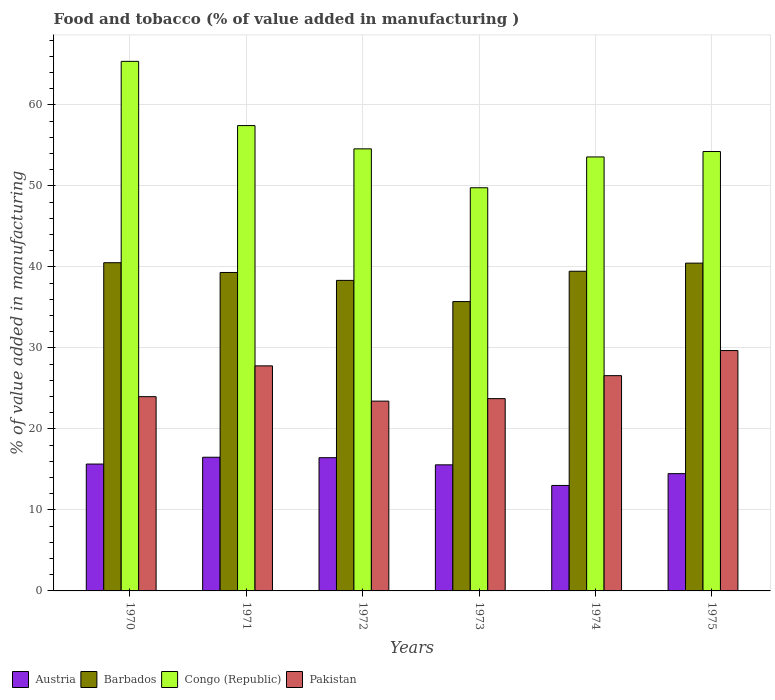How many different coloured bars are there?
Provide a short and direct response. 4. Are the number of bars per tick equal to the number of legend labels?
Provide a short and direct response. Yes. How many bars are there on the 2nd tick from the left?
Ensure brevity in your answer.  4. How many bars are there on the 2nd tick from the right?
Provide a short and direct response. 4. What is the label of the 6th group of bars from the left?
Your answer should be very brief. 1975. What is the value added in manufacturing food and tobacco in Pakistan in 1971?
Give a very brief answer. 27.78. Across all years, what is the maximum value added in manufacturing food and tobacco in Pakistan?
Ensure brevity in your answer.  29.67. Across all years, what is the minimum value added in manufacturing food and tobacco in Austria?
Your response must be concise. 13.02. In which year was the value added in manufacturing food and tobacco in Austria minimum?
Your answer should be very brief. 1974. What is the total value added in manufacturing food and tobacco in Barbados in the graph?
Your answer should be very brief. 233.8. What is the difference between the value added in manufacturing food and tobacco in Barbados in 1970 and that in 1975?
Keep it short and to the point. 0.05. What is the difference between the value added in manufacturing food and tobacco in Congo (Republic) in 1972 and the value added in manufacturing food and tobacco in Pakistan in 1971?
Offer a terse response. 26.79. What is the average value added in manufacturing food and tobacco in Congo (Republic) per year?
Keep it short and to the point. 55.83. In the year 1973, what is the difference between the value added in manufacturing food and tobacco in Congo (Republic) and value added in manufacturing food and tobacco in Austria?
Your answer should be compact. 34.2. In how many years, is the value added in manufacturing food and tobacco in Austria greater than 42 %?
Your answer should be compact. 0. What is the ratio of the value added in manufacturing food and tobacco in Congo (Republic) in 1973 to that in 1974?
Provide a short and direct response. 0.93. Is the value added in manufacturing food and tobacco in Barbados in 1970 less than that in 1973?
Your answer should be compact. No. Is the difference between the value added in manufacturing food and tobacco in Congo (Republic) in 1972 and 1975 greater than the difference between the value added in manufacturing food and tobacco in Austria in 1972 and 1975?
Give a very brief answer. No. What is the difference between the highest and the second highest value added in manufacturing food and tobacco in Barbados?
Keep it short and to the point. 0.05. What is the difference between the highest and the lowest value added in manufacturing food and tobacco in Barbados?
Keep it short and to the point. 4.8. In how many years, is the value added in manufacturing food and tobacco in Congo (Republic) greater than the average value added in manufacturing food and tobacco in Congo (Republic) taken over all years?
Ensure brevity in your answer.  2. Is the sum of the value added in manufacturing food and tobacco in Barbados in 1974 and 1975 greater than the maximum value added in manufacturing food and tobacco in Congo (Republic) across all years?
Offer a terse response. Yes. What does the 4th bar from the left in 1971 represents?
Provide a short and direct response. Pakistan. What is the difference between two consecutive major ticks on the Y-axis?
Your answer should be very brief. 10. How are the legend labels stacked?
Your answer should be very brief. Horizontal. What is the title of the graph?
Keep it short and to the point. Food and tobacco (% of value added in manufacturing ). Does "New Caledonia" appear as one of the legend labels in the graph?
Your answer should be compact. No. What is the label or title of the Y-axis?
Make the answer very short. % of value added in manufacturing. What is the % of value added in manufacturing of Austria in 1970?
Offer a terse response. 15.66. What is the % of value added in manufacturing of Barbados in 1970?
Offer a terse response. 40.51. What is the % of value added in manufacturing of Congo (Republic) in 1970?
Your answer should be compact. 65.37. What is the % of value added in manufacturing in Pakistan in 1970?
Give a very brief answer. 23.98. What is the % of value added in manufacturing of Austria in 1971?
Offer a terse response. 16.5. What is the % of value added in manufacturing in Barbados in 1971?
Your answer should be compact. 39.31. What is the % of value added in manufacturing of Congo (Republic) in 1971?
Your answer should be very brief. 57.44. What is the % of value added in manufacturing in Pakistan in 1971?
Provide a short and direct response. 27.78. What is the % of value added in manufacturing in Austria in 1972?
Provide a short and direct response. 16.45. What is the % of value added in manufacturing of Barbados in 1972?
Your answer should be compact. 38.33. What is the % of value added in manufacturing in Congo (Republic) in 1972?
Your response must be concise. 54.57. What is the % of value added in manufacturing in Pakistan in 1972?
Give a very brief answer. 23.43. What is the % of value added in manufacturing in Austria in 1973?
Provide a succinct answer. 15.56. What is the % of value added in manufacturing of Barbados in 1973?
Give a very brief answer. 35.72. What is the % of value added in manufacturing in Congo (Republic) in 1973?
Ensure brevity in your answer.  49.77. What is the % of value added in manufacturing in Pakistan in 1973?
Offer a very short reply. 23.74. What is the % of value added in manufacturing in Austria in 1974?
Make the answer very short. 13.02. What is the % of value added in manufacturing of Barbados in 1974?
Keep it short and to the point. 39.46. What is the % of value added in manufacturing of Congo (Republic) in 1974?
Provide a short and direct response. 53.57. What is the % of value added in manufacturing in Pakistan in 1974?
Make the answer very short. 26.57. What is the % of value added in manufacturing in Austria in 1975?
Ensure brevity in your answer.  14.48. What is the % of value added in manufacturing in Barbados in 1975?
Your response must be concise. 40.46. What is the % of value added in manufacturing of Congo (Republic) in 1975?
Provide a succinct answer. 54.24. What is the % of value added in manufacturing of Pakistan in 1975?
Your response must be concise. 29.67. Across all years, what is the maximum % of value added in manufacturing in Austria?
Ensure brevity in your answer.  16.5. Across all years, what is the maximum % of value added in manufacturing in Barbados?
Provide a short and direct response. 40.51. Across all years, what is the maximum % of value added in manufacturing of Congo (Republic)?
Give a very brief answer. 65.37. Across all years, what is the maximum % of value added in manufacturing in Pakistan?
Offer a terse response. 29.67. Across all years, what is the minimum % of value added in manufacturing in Austria?
Give a very brief answer. 13.02. Across all years, what is the minimum % of value added in manufacturing in Barbados?
Your answer should be compact. 35.72. Across all years, what is the minimum % of value added in manufacturing of Congo (Republic)?
Offer a terse response. 49.77. Across all years, what is the minimum % of value added in manufacturing in Pakistan?
Make the answer very short. 23.43. What is the total % of value added in manufacturing in Austria in the graph?
Ensure brevity in your answer.  91.67. What is the total % of value added in manufacturing in Barbados in the graph?
Ensure brevity in your answer.  233.8. What is the total % of value added in manufacturing of Congo (Republic) in the graph?
Give a very brief answer. 334.96. What is the total % of value added in manufacturing of Pakistan in the graph?
Provide a short and direct response. 155.17. What is the difference between the % of value added in manufacturing of Austria in 1970 and that in 1971?
Ensure brevity in your answer.  -0.84. What is the difference between the % of value added in manufacturing of Barbados in 1970 and that in 1971?
Give a very brief answer. 1.21. What is the difference between the % of value added in manufacturing in Congo (Republic) in 1970 and that in 1971?
Your answer should be compact. 7.93. What is the difference between the % of value added in manufacturing of Pakistan in 1970 and that in 1971?
Offer a very short reply. -3.8. What is the difference between the % of value added in manufacturing in Austria in 1970 and that in 1972?
Offer a terse response. -0.79. What is the difference between the % of value added in manufacturing of Barbados in 1970 and that in 1972?
Give a very brief answer. 2.18. What is the difference between the % of value added in manufacturing of Congo (Republic) in 1970 and that in 1972?
Ensure brevity in your answer.  10.8. What is the difference between the % of value added in manufacturing in Pakistan in 1970 and that in 1972?
Offer a terse response. 0.55. What is the difference between the % of value added in manufacturing of Austria in 1970 and that in 1973?
Your answer should be very brief. 0.1. What is the difference between the % of value added in manufacturing in Barbados in 1970 and that in 1973?
Offer a terse response. 4.8. What is the difference between the % of value added in manufacturing in Congo (Republic) in 1970 and that in 1973?
Give a very brief answer. 15.6. What is the difference between the % of value added in manufacturing of Pakistan in 1970 and that in 1973?
Offer a very short reply. 0.24. What is the difference between the % of value added in manufacturing in Austria in 1970 and that in 1974?
Your answer should be very brief. 2.64. What is the difference between the % of value added in manufacturing in Barbados in 1970 and that in 1974?
Offer a very short reply. 1.05. What is the difference between the % of value added in manufacturing of Congo (Republic) in 1970 and that in 1974?
Give a very brief answer. 11.8. What is the difference between the % of value added in manufacturing in Pakistan in 1970 and that in 1974?
Provide a succinct answer. -2.59. What is the difference between the % of value added in manufacturing of Austria in 1970 and that in 1975?
Ensure brevity in your answer.  1.18. What is the difference between the % of value added in manufacturing of Barbados in 1970 and that in 1975?
Provide a short and direct response. 0.05. What is the difference between the % of value added in manufacturing of Congo (Republic) in 1970 and that in 1975?
Give a very brief answer. 11.13. What is the difference between the % of value added in manufacturing in Pakistan in 1970 and that in 1975?
Ensure brevity in your answer.  -5.69. What is the difference between the % of value added in manufacturing in Austria in 1971 and that in 1972?
Keep it short and to the point. 0.06. What is the difference between the % of value added in manufacturing of Barbados in 1971 and that in 1972?
Your answer should be very brief. 0.97. What is the difference between the % of value added in manufacturing of Congo (Republic) in 1971 and that in 1972?
Keep it short and to the point. 2.87. What is the difference between the % of value added in manufacturing in Pakistan in 1971 and that in 1972?
Give a very brief answer. 4.35. What is the difference between the % of value added in manufacturing in Austria in 1971 and that in 1973?
Your answer should be very brief. 0.94. What is the difference between the % of value added in manufacturing in Barbados in 1971 and that in 1973?
Your answer should be very brief. 3.59. What is the difference between the % of value added in manufacturing in Congo (Republic) in 1971 and that in 1973?
Your answer should be very brief. 7.67. What is the difference between the % of value added in manufacturing of Pakistan in 1971 and that in 1973?
Your response must be concise. 4.05. What is the difference between the % of value added in manufacturing in Austria in 1971 and that in 1974?
Provide a succinct answer. 3.48. What is the difference between the % of value added in manufacturing of Barbados in 1971 and that in 1974?
Give a very brief answer. -0.15. What is the difference between the % of value added in manufacturing in Congo (Republic) in 1971 and that in 1974?
Offer a very short reply. 3.87. What is the difference between the % of value added in manufacturing in Pakistan in 1971 and that in 1974?
Your response must be concise. 1.21. What is the difference between the % of value added in manufacturing of Austria in 1971 and that in 1975?
Keep it short and to the point. 2.03. What is the difference between the % of value added in manufacturing of Barbados in 1971 and that in 1975?
Keep it short and to the point. -1.15. What is the difference between the % of value added in manufacturing of Congo (Republic) in 1971 and that in 1975?
Keep it short and to the point. 3.2. What is the difference between the % of value added in manufacturing in Pakistan in 1971 and that in 1975?
Offer a terse response. -1.89. What is the difference between the % of value added in manufacturing of Austria in 1972 and that in 1973?
Your answer should be very brief. 0.88. What is the difference between the % of value added in manufacturing in Barbados in 1972 and that in 1973?
Your response must be concise. 2.62. What is the difference between the % of value added in manufacturing in Congo (Republic) in 1972 and that in 1973?
Your answer should be compact. 4.8. What is the difference between the % of value added in manufacturing of Pakistan in 1972 and that in 1973?
Keep it short and to the point. -0.31. What is the difference between the % of value added in manufacturing in Austria in 1972 and that in 1974?
Keep it short and to the point. 3.43. What is the difference between the % of value added in manufacturing of Barbados in 1972 and that in 1974?
Offer a very short reply. -1.13. What is the difference between the % of value added in manufacturing in Congo (Republic) in 1972 and that in 1974?
Give a very brief answer. 1. What is the difference between the % of value added in manufacturing in Pakistan in 1972 and that in 1974?
Your answer should be very brief. -3.15. What is the difference between the % of value added in manufacturing in Austria in 1972 and that in 1975?
Your answer should be compact. 1.97. What is the difference between the % of value added in manufacturing in Barbados in 1972 and that in 1975?
Make the answer very short. -2.13. What is the difference between the % of value added in manufacturing in Congo (Republic) in 1972 and that in 1975?
Offer a very short reply. 0.33. What is the difference between the % of value added in manufacturing of Pakistan in 1972 and that in 1975?
Offer a terse response. -6.24. What is the difference between the % of value added in manufacturing of Austria in 1973 and that in 1974?
Provide a short and direct response. 2.54. What is the difference between the % of value added in manufacturing in Barbados in 1973 and that in 1974?
Your answer should be very brief. -3.74. What is the difference between the % of value added in manufacturing of Congo (Republic) in 1973 and that in 1974?
Offer a very short reply. -3.8. What is the difference between the % of value added in manufacturing of Pakistan in 1973 and that in 1974?
Ensure brevity in your answer.  -2.84. What is the difference between the % of value added in manufacturing of Austria in 1973 and that in 1975?
Ensure brevity in your answer.  1.09. What is the difference between the % of value added in manufacturing of Barbados in 1973 and that in 1975?
Ensure brevity in your answer.  -4.74. What is the difference between the % of value added in manufacturing in Congo (Republic) in 1973 and that in 1975?
Your response must be concise. -4.47. What is the difference between the % of value added in manufacturing in Pakistan in 1973 and that in 1975?
Your answer should be compact. -5.94. What is the difference between the % of value added in manufacturing of Austria in 1974 and that in 1975?
Offer a terse response. -1.46. What is the difference between the % of value added in manufacturing of Barbados in 1974 and that in 1975?
Your answer should be very brief. -1. What is the difference between the % of value added in manufacturing in Congo (Republic) in 1974 and that in 1975?
Your answer should be very brief. -0.67. What is the difference between the % of value added in manufacturing in Pakistan in 1974 and that in 1975?
Your response must be concise. -3.1. What is the difference between the % of value added in manufacturing in Austria in 1970 and the % of value added in manufacturing in Barbados in 1971?
Offer a very short reply. -23.65. What is the difference between the % of value added in manufacturing in Austria in 1970 and the % of value added in manufacturing in Congo (Republic) in 1971?
Give a very brief answer. -41.78. What is the difference between the % of value added in manufacturing in Austria in 1970 and the % of value added in manufacturing in Pakistan in 1971?
Your response must be concise. -12.12. What is the difference between the % of value added in manufacturing in Barbados in 1970 and the % of value added in manufacturing in Congo (Republic) in 1971?
Your answer should be compact. -16.93. What is the difference between the % of value added in manufacturing of Barbados in 1970 and the % of value added in manufacturing of Pakistan in 1971?
Your answer should be very brief. 12.73. What is the difference between the % of value added in manufacturing of Congo (Republic) in 1970 and the % of value added in manufacturing of Pakistan in 1971?
Provide a short and direct response. 37.59. What is the difference between the % of value added in manufacturing in Austria in 1970 and the % of value added in manufacturing in Barbados in 1972?
Your answer should be compact. -22.67. What is the difference between the % of value added in manufacturing in Austria in 1970 and the % of value added in manufacturing in Congo (Republic) in 1972?
Give a very brief answer. -38.91. What is the difference between the % of value added in manufacturing in Austria in 1970 and the % of value added in manufacturing in Pakistan in 1972?
Your answer should be compact. -7.77. What is the difference between the % of value added in manufacturing in Barbados in 1970 and the % of value added in manufacturing in Congo (Republic) in 1972?
Keep it short and to the point. -14.06. What is the difference between the % of value added in manufacturing of Barbados in 1970 and the % of value added in manufacturing of Pakistan in 1972?
Your response must be concise. 17.09. What is the difference between the % of value added in manufacturing of Congo (Republic) in 1970 and the % of value added in manufacturing of Pakistan in 1972?
Ensure brevity in your answer.  41.94. What is the difference between the % of value added in manufacturing in Austria in 1970 and the % of value added in manufacturing in Barbados in 1973?
Your answer should be compact. -20.06. What is the difference between the % of value added in manufacturing of Austria in 1970 and the % of value added in manufacturing of Congo (Republic) in 1973?
Your response must be concise. -34.11. What is the difference between the % of value added in manufacturing in Austria in 1970 and the % of value added in manufacturing in Pakistan in 1973?
Your answer should be compact. -8.08. What is the difference between the % of value added in manufacturing of Barbados in 1970 and the % of value added in manufacturing of Congo (Republic) in 1973?
Give a very brief answer. -9.25. What is the difference between the % of value added in manufacturing of Barbados in 1970 and the % of value added in manufacturing of Pakistan in 1973?
Offer a terse response. 16.78. What is the difference between the % of value added in manufacturing of Congo (Republic) in 1970 and the % of value added in manufacturing of Pakistan in 1973?
Offer a very short reply. 41.63. What is the difference between the % of value added in manufacturing of Austria in 1970 and the % of value added in manufacturing of Barbados in 1974?
Offer a terse response. -23.8. What is the difference between the % of value added in manufacturing of Austria in 1970 and the % of value added in manufacturing of Congo (Republic) in 1974?
Provide a succinct answer. -37.91. What is the difference between the % of value added in manufacturing of Austria in 1970 and the % of value added in manufacturing of Pakistan in 1974?
Your response must be concise. -10.91. What is the difference between the % of value added in manufacturing of Barbados in 1970 and the % of value added in manufacturing of Congo (Republic) in 1974?
Provide a short and direct response. -13.06. What is the difference between the % of value added in manufacturing of Barbados in 1970 and the % of value added in manufacturing of Pakistan in 1974?
Offer a terse response. 13.94. What is the difference between the % of value added in manufacturing in Congo (Republic) in 1970 and the % of value added in manufacturing in Pakistan in 1974?
Your answer should be compact. 38.8. What is the difference between the % of value added in manufacturing in Austria in 1970 and the % of value added in manufacturing in Barbados in 1975?
Give a very brief answer. -24.8. What is the difference between the % of value added in manufacturing of Austria in 1970 and the % of value added in manufacturing of Congo (Republic) in 1975?
Your response must be concise. -38.58. What is the difference between the % of value added in manufacturing in Austria in 1970 and the % of value added in manufacturing in Pakistan in 1975?
Ensure brevity in your answer.  -14.01. What is the difference between the % of value added in manufacturing in Barbados in 1970 and the % of value added in manufacturing in Congo (Republic) in 1975?
Your response must be concise. -13.73. What is the difference between the % of value added in manufacturing of Barbados in 1970 and the % of value added in manufacturing of Pakistan in 1975?
Your answer should be very brief. 10.84. What is the difference between the % of value added in manufacturing in Congo (Republic) in 1970 and the % of value added in manufacturing in Pakistan in 1975?
Keep it short and to the point. 35.7. What is the difference between the % of value added in manufacturing in Austria in 1971 and the % of value added in manufacturing in Barbados in 1972?
Ensure brevity in your answer.  -21.83. What is the difference between the % of value added in manufacturing of Austria in 1971 and the % of value added in manufacturing of Congo (Republic) in 1972?
Give a very brief answer. -38.07. What is the difference between the % of value added in manufacturing in Austria in 1971 and the % of value added in manufacturing in Pakistan in 1972?
Provide a short and direct response. -6.93. What is the difference between the % of value added in manufacturing in Barbados in 1971 and the % of value added in manufacturing in Congo (Republic) in 1972?
Offer a very short reply. -15.26. What is the difference between the % of value added in manufacturing in Barbados in 1971 and the % of value added in manufacturing in Pakistan in 1972?
Keep it short and to the point. 15.88. What is the difference between the % of value added in manufacturing in Congo (Republic) in 1971 and the % of value added in manufacturing in Pakistan in 1972?
Your answer should be very brief. 34.01. What is the difference between the % of value added in manufacturing in Austria in 1971 and the % of value added in manufacturing in Barbados in 1973?
Your response must be concise. -19.22. What is the difference between the % of value added in manufacturing in Austria in 1971 and the % of value added in manufacturing in Congo (Republic) in 1973?
Your answer should be very brief. -33.26. What is the difference between the % of value added in manufacturing of Austria in 1971 and the % of value added in manufacturing of Pakistan in 1973?
Your response must be concise. -7.23. What is the difference between the % of value added in manufacturing in Barbados in 1971 and the % of value added in manufacturing in Congo (Republic) in 1973?
Keep it short and to the point. -10.46. What is the difference between the % of value added in manufacturing of Barbados in 1971 and the % of value added in manufacturing of Pakistan in 1973?
Offer a terse response. 15.57. What is the difference between the % of value added in manufacturing of Congo (Republic) in 1971 and the % of value added in manufacturing of Pakistan in 1973?
Make the answer very short. 33.71. What is the difference between the % of value added in manufacturing of Austria in 1971 and the % of value added in manufacturing of Barbados in 1974?
Give a very brief answer. -22.96. What is the difference between the % of value added in manufacturing in Austria in 1971 and the % of value added in manufacturing in Congo (Republic) in 1974?
Offer a very short reply. -37.07. What is the difference between the % of value added in manufacturing of Austria in 1971 and the % of value added in manufacturing of Pakistan in 1974?
Give a very brief answer. -10.07. What is the difference between the % of value added in manufacturing of Barbados in 1971 and the % of value added in manufacturing of Congo (Republic) in 1974?
Offer a very short reply. -14.26. What is the difference between the % of value added in manufacturing in Barbados in 1971 and the % of value added in manufacturing in Pakistan in 1974?
Your answer should be very brief. 12.74. What is the difference between the % of value added in manufacturing of Congo (Republic) in 1971 and the % of value added in manufacturing of Pakistan in 1974?
Give a very brief answer. 30.87. What is the difference between the % of value added in manufacturing of Austria in 1971 and the % of value added in manufacturing of Barbados in 1975?
Make the answer very short. -23.96. What is the difference between the % of value added in manufacturing in Austria in 1971 and the % of value added in manufacturing in Congo (Republic) in 1975?
Your response must be concise. -37.74. What is the difference between the % of value added in manufacturing in Austria in 1971 and the % of value added in manufacturing in Pakistan in 1975?
Ensure brevity in your answer.  -13.17. What is the difference between the % of value added in manufacturing of Barbados in 1971 and the % of value added in manufacturing of Congo (Republic) in 1975?
Give a very brief answer. -14.93. What is the difference between the % of value added in manufacturing of Barbados in 1971 and the % of value added in manufacturing of Pakistan in 1975?
Provide a succinct answer. 9.64. What is the difference between the % of value added in manufacturing in Congo (Republic) in 1971 and the % of value added in manufacturing in Pakistan in 1975?
Ensure brevity in your answer.  27.77. What is the difference between the % of value added in manufacturing of Austria in 1972 and the % of value added in manufacturing of Barbados in 1973?
Offer a very short reply. -19.27. What is the difference between the % of value added in manufacturing in Austria in 1972 and the % of value added in manufacturing in Congo (Republic) in 1973?
Make the answer very short. -33.32. What is the difference between the % of value added in manufacturing of Austria in 1972 and the % of value added in manufacturing of Pakistan in 1973?
Offer a very short reply. -7.29. What is the difference between the % of value added in manufacturing in Barbados in 1972 and the % of value added in manufacturing in Congo (Republic) in 1973?
Offer a terse response. -11.43. What is the difference between the % of value added in manufacturing in Barbados in 1972 and the % of value added in manufacturing in Pakistan in 1973?
Offer a terse response. 14.6. What is the difference between the % of value added in manufacturing of Congo (Republic) in 1972 and the % of value added in manufacturing of Pakistan in 1973?
Your answer should be compact. 30.83. What is the difference between the % of value added in manufacturing of Austria in 1972 and the % of value added in manufacturing of Barbados in 1974?
Give a very brief answer. -23.02. What is the difference between the % of value added in manufacturing in Austria in 1972 and the % of value added in manufacturing in Congo (Republic) in 1974?
Your response must be concise. -37.12. What is the difference between the % of value added in manufacturing in Austria in 1972 and the % of value added in manufacturing in Pakistan in 1974?
Offer a very short reply. -10.13. What is the difference between the % of value added in manufacturing in Barbados in 1972 and the % of value added in manufacturing in Congo (Republic) in 1974?
Make the answer very short. -15.24. What is the difference between the % of value added in manufacturing of Barbados in 1972 and the % of value added in manufacturing of Pakistan in 1974?
Offer a terse response. 11.76. What is the difference between the % of value added in manufacturing in Congo (Republic) in 1972 and the % of value added in manufacturing in Pakistan in 1974?
Make the answer very short. 28. What is the difference between the % of value added in manufacturing in Austria in 1972 and the % of value added in manufacturing in Barbados in 1975?
Your response must be concise. -24.02. What is the difference between the % of value added in manufacturing of Austria in 1972 and the % of value added in manufacturing of Congo (Republic) in 1975?
Offer a terse response. -37.79. What is the difference between the % of value added in manufacturing of Austria in 1972 and the % of value added in manufacturing of Pakistan in 1975?
Give a very brief answer. -13.23. What is the difference between the % of value added in manufacturing in Barbados in 1972 and the % of value added in manufacturing in Congo (Republic) in 1975?
Your answer should be very brief. -15.91. What is the difference between the % of value added in manufacturing of Barbados in 1972 and the % of value added in manufacturing of Pakistan in 1975?
Provide a short and direct response. 8.66. What is the difference between the % of value added in manufacturing of Congo (Republic) in 1972 and the % of value added in manufacturing of Pakistan in 1975?
Your answer should be compact. 24.9. What is the difference between the % of value added in manufacturing in Austria in 1973 and the % of value added in manufacturing in Barbados in 1974?
Keep it short and to the point. -23.9. What is the difference between the % of value added in manufacturing of Austria in 1973 and the % of value added in manufacturing of Congo (Republic) in 1974?
Make the answer very short. -38.01. What is the difference between the % of value added in manufacturing in Austria in 1973 and the % of value added in manufacturing in Pakistan in 1974?
Ensure brevity in your answer.  -11.01. What is the difference between the % of value added in manufacturing in Barbados in 1973 and the % of value added in manufacturing in Congo (Republic) in 1974?
Provide a succinct answer. -17.85. What is the difference between the % of value added in manufacturing in Barbados in 1973 and the % of value added in manufacturing in Pakistan in 1974?
Offer a terse response. 9.15. What is the difference between the % of value added in manufacturing of Congo (Republic) in 1973 and the % of value added in manufacturing of Pakistan in 1974?
Your response must be concise. 23.19. What is the difference between the % of value added in manufacturing of Austria in 1973 and the % of value added in manufacturing of Barbados in 1975?
Make the answer very short. -24.9. What is the difference between the % of value added in manufacturing of Austria in 1973 and the % of value added in manufacturing of Congo (Republic) in 1975?
Provide a succinct answer. -38.68. What is the difference between the % of value added in manufacturing in Austria in 1973 and the % of value added in manufacturing in Pakistan in 1975?
Your answer should be very brief. -14.11. What is the difference between the % of value added in manufacturing in Barbados in 1973 and the % of value added in manufacturing in Congo (Republic) in 1975?
Provide a short and direct response. -18.52. What is the difference between the % of value added in manufacturing of Barbados in 1973 and the % of value added in manufacturing of Pakistan in 1975?
Keep it short and to the point. 6.05. What is the difference between the % of value added in manufacturing in Congo (Republic) in 1973 and the % of value added in manufacturing in Pakistan in 1975?
Make the answer very short. 20.1. What is the difference between the % of value added in manufacturing of Austria in 1974 and the % of value added in manufacturing of Barbados in 1975?
Provide a short and direct response. -27.44. What is the difference between the % of value added in manufacturing of Austria in 1974 and the % of value added in manufacturing of Congo (Republic) in 1975?
Ensure brevity in your answer.  -41.22. What is the difference between the % of value added in manufacturing in Austria in 1974 and the % of value added in manufacturing in Pakistan in 1975?
Provide a succinct answer. -16.65. What is the difference between the % of value added in manufacturing of Barbados in 1974 and the % of value added in manufacturing of Congo (Republic) in 1975?
Your answer should be compact. -14.78. What is the difference between the % of value added in manufacturing of Barbados in 1974 and the % of value added in manufacturing of Pakistan in 1975?
Your answer should be compact. 9.79. What is the difference between the % of value added in manufacturing in Congo (Republic) in 1974 and the % of value added in manufacturing in Pakistan in 1975?
Provide a short and direct response. 23.9. What is the average % of value added in manufacturing of Austria per year?
Your answer should be compact. 15.28. What is the average % of value added in manufacturing of Barbados per year?
Your answer should be compact. 38.97. What is the average % of value added in manufacturing of Congo (Republic) per year?
Your answer should be very brief. 55.83. What is the average % of value added in manufacturing of Pakistan per year?
Ensure brevity in your answer.  25.86. In the year 1970, what is the difference between the % of value added in manufacturing in Austria and % of value added in manufacturing in Barbados?
Provide a succinct answer. -24.85. In the year 1970, what is the difference between the % of value added in manufacturing in Austria and % of value added in manufacturing in Congo (Republic)?
Your response must be concise. -49.71. In the year 1970, what is the difference between the % of value added in manufacturing of Austria and % of value added in manufacturing of Pakistan?
Offer a terse response. -8.32. In the year 1970, what is the difference between the % of value added in manufacturing of Barbados and % of value added in manufacturing of Congo (Republic)?
Offer a terse response. -24.86. In the year 1970, what is the difference between the % of value added in manufacturing of Barbados and % of value added in manufacturing of Pakistan?
Offer a very short reply. 16.54. In the year 1970, what is the difference between the % of value added in manufacturing in Congo (Republic) and % of value added in manufacturing in Pakistan?
Offer a terse response. 41.39. In the year 1971, what is the difference between the % of value added in manufacturing of Austria and % of value added in manufacturing of Barbados?
Provide a succinct answer. -22.81. In the year 1971, what is the difference between the % of value added in manufacturing in Austria and % of value added in manufacturing in Congo (Republic)?
Provide a short and direct response. -40.94. In the year 1971, what is the difference between the % of value added in manufacturing in Austria and % of value added in manufacturing in Pakistan?
Make the answer very short. -11.28. In the year 1971, what is the difference between the % of value added in manufacturing of Barbados and % of value added in manufacturing of Congo (Republic)?
Your response must be concise. -18.13. In the year 1971, what is the difference between the % of value added in manufacturing of Barbados and % of value added in manufacturing of Pakistan?
Your response must be concise. 11.53. In the year 1971, what is the difference between the % of value added in manufacturing in Congo (Republic) and % of value added in manufacturing in Pakistan?
Offer a very short reply. 29.66. In the year 1972, what is the difference between the % of value added in manufacturing in Austria and % of value added in manufacturing in Barbados?
Provide a short and direct response. -21.89. In the year 1972, what is the difference between the % of value added in manufacturing in Austria and % of value added in manufacturing in Congo (Republic)?
Offer a very short reply. -38.12. In the year 1972, what is the difference between the % of value added in manufacturing in Austria and % of value added in manufacturing in Pakistan?
Offer a terse response. -6.98. In the year 1972, what is the difference between the % of value added in manufacturing in Barbados and % of value added in manufacturing in Congo (Republic)?
Offer a terse response. -16.24. In the year 1972, what is the difference between the % of value added in manufacturing of Barbados and % of value added in manufacturing of Pakistan?
Ensure brevity in your answer.  14.91. In the year 1972, what is the difference between the % of value added in manufacturing in Congo (Republic) and % of value added in manufacturing in Pakistan?
Offer a very short reply. 31.14. In the year 1973, what is the difference between the % of value added in manufacturing of Austria and % of value added in manufacturing of Barbados?
Offer a very short reply. -20.16. In the year 1973, what is the difference between the % of value added in manufacturing of Austria and % of value added in manufacturing of Congo (Republic)?
Keep it short and to the point. -34.2. In the year 1973, what is the difference between the % of value added in manufacturing of Austria and % of value added in manufacturing of Pakistan?
Make the answer very short. -8.17. In the year 1973, what is the difference between the % of value added in manufacturing in Barbados and % of value added in manufacturing in Congo (Republic)?
Keep it short and to the point. -14.05. In the year 1973, what is the difference between the % of value added in manufacturing of Barbados and % of value added in manufacturing of Pakistan?
Provide a short and direct response. 11.98. In the year 1973, what is the difference between the % of value added in manufacturing of Congo (Republic) and % of value added in manufacturing of Pakistan?
Provide a succinct answer. 26.03. In the year 1974, what is the difference between the % of value added in manufacturing of Austria and % of value added in manufacturing of Barbados?
Provide a succinct answer. -26.44. In the year 1974, what is the difference between the % of value added in manufacturing in Austria and % of value added in manufacturing in Congo (Republic)?
Your answer should be compact. -40.55. In the year 1974, what is the difference between the % of value added in manufacturing of Austria and % of value added in manufacturing of Pakistan?
Your answer should be very brief. -13.55. In the year 1974, what is the difference between the % of value added in manufacturing of Barbados and % of value added in manufacturing of Congo (Republic)?
Offer a very short reply. -14.11. In the year 1974, what is the difference between the % of value added in manufacturing in Barbados and % of value added in manufacturing in Pakistan?
Your response must be concise. 12.89. In the year 1974, what is the difference between the % of value added in manufacturing in Congo (Republic) and % of value added in manufacturing in Pakistan?
Offer a terse response. 27. In the year 1975, what is the difference between the % of value added in manufacturing in Austria and % of value added in manufacturing in Barbados?
Offer a terse response. -25.99. In the year 1975, what is the difference between the % of value added in manufacturing of Austria and % of value added in manufacturing of Congo (Republic)?
Your answer should be compact. -39.76. In the year 1975, what is the difference between the % of value added in manufacturing in Austria and % of value added in manufacturing in Pakistan?
Your answer should be very brief. -15.2. In the year 1975, what is the difference between the % of value added in manufacturing in Barbados and % of value added in manufacturing in Congo (Republic)?
Provide a short and direct response. -13.78. In the year 1975, what is the difference between the % of value added in manufacturing in Barbados and % of value added in manufacturing in Pakistan?
Your answer should be compact. 10.79. In the year 1975, what is the difference between the % of value added in manufacturing of Congo (Republic) and % of value added in manufacturing of Pakistan?
Your answer should be very brief. 24.57. What is the ratio of the % of value added in manufacturing in Austria in 1970 to that in 1971?
Keep it short and to the point. 0.95. What is the ratio of the % of value added in manufacturing in Barbados in 1970 to that in 1971?
Keep it short and to the point. 1.03. What is the ratio of the % of value added in manufacturing of Congo (Republic) in 1970 to that in 1971?
Offer a very short reply. 1.14. What is the ratio of the % of value added in manufacturing of Pakistan in 1970 to that in 1971?
Provide a succinct answer. 0.86. What is the ratio of the % of value added in manufacturing in Austria in 1970 to that in 1972?
Provide a short and direct response. 0.95. What is the ratio of the % of value added in manufacturing of Barbados in 1970 to that in 1972?
Your response must be concise. 1.06. What is the ratio of the % of value added in manufacturing of Congo (Republic) in 1970 to that in 1972?
Offer a terse response. 1.2. What is the ratio of the % of value added in manufacturing in Pakistan in 1970 to that in 1972?
Your answer should be very brief. 1.02. What is the ratio of the % of value added in manufacturing in Barbados in 1970 to that in 1973?
Offer a terse response. 1.13. What is the ratio of the % of value added in manufacturing in Congo (Republic) in 1970 to that in 1973?
Keep it short and to the point. 1.31. What is the ratio of the % of value added in manufacturing in Pakistan in 1970 to that in 1973?
Offer a terse response. 1.01. What is the ratio of the % of value added in manufacturing of Austria in 1970 to that in 1974?
Give a very brief answer. 1.2. What is the ratio of the % of value added in manufacturing of Barbados in 1970 to that in 1974?
Your answer should be very brief. 1.03. What is the ratio of the % of value added in manufacturing of Congo (Republic) in 1970 to that in 1974?
Give a very brief answer. 1.22. What is the ratio of the % of value added in manufacturing in Pakistan in 1970 to that in 1974?
Your answer should be very brief. 0.9. What is the ratio of the % of value added in manufacturing of Austria in 1970 to that in 1975?
Provide a succinct answer. 1.08. What is the ratio of the % of value added in manufacturing of Barbados in 1970 to that in 1975?
Offer a terse response. 1. What is the ratio of the % of value added in manufacturing of Congo (Republic) in 1970 to that in 1975?
Give a very brief answer. 1.21. What is the ratio of the % of value added in manufacturing of Pakistan in 1970 to that in 1975?
Make the answer very short. 0.81. What is the ratio of the % of value added in manufacturing of Barbados in 1971 to that in 1972?
Offer a terse response. 1.03. What is the ratio of the % of value added in manufacturing of Congo (Republic) in 1971 to that in 1972?
Your answer should be very brief. 1.05. What is the ratio of the % of value added in manufacturing in Pakistan in 1971 to that in 1972?
Your answer should be compact. 1.19. What is the ratio of the % of value added in manufacturing of Austria in 1971 to that in 1973?
Provide a short and direct response. 1.06. What is the ratio of the % of value added in manufacturing of Barbados in 1971 to that in 1973?
Offer a terse response. 1.1. What is the ratio of the % of value added in manufacturing of Congo (Republic) in 1971 to that in 1973?
Ensure brevity in your answer.  1.15. What is the ratio of the % of value added in manufacturing of Pakistan in 1971 to that in 1973?
Your answer should be compact. 1.17. What is the ratio of the % of value added in manufacturing of Austria in 1971 to that in 1974?
Provide a succinct answer. 1.27. What is the ratio of the % of value added in manufacturing in Congo (Republic) in 1971 to that in 1974?
Provide a succinct answer. 1.07. What is the ratio of the % of value added in manufacturing in Pakistan in 1971 to that in 1974?
Keep it short and to the point. 1.05. What is the ratio of the % of value added in manufacturing of Austria in 1971 to that in 1975?
Your response must be concise. 1.14. What is the ratio of the % of value added in manufacturing in Barbados in 1971 to that in 1975?
Provide a succinct answer. 0.97. What is the ratio of the % of value added in manufacturing of Congo (Republic) in 1971 to that in 1975?
Provide a short and direct response. 1.06. What is the ratio of the % of value added in manufacturing of Pakistan in 1971 to that in 1975?
Keep it short and to the point. 0.94. What is the ratio of the % of value added in manufacturing of Austria in 1972 to that in 1973?
Keep it short and to the point. 1.06. What is the ratio of the % of value added in manufacturing in Barbados in 1972 to that in 1973?
Your answer should be very brief. 1.07. What is the ratio of the % of value added in manufacturing of Congo (Republic) in 1972 to that in 1973?
Provide a succinct answer. 1.1. What is the ratio of the % of value added in manufacturing in Austria in 1972 to that in 1974?
Offer a terse response. 1.26. What is the ratio of the % of value added in manufacturing of Barbados in 1972 to that in 1974?
Provide a succinct answer. 0.97. What is the ratio of the % of value added in manufacturing in Congo (Republic) in 1972 to that in 1974?
Make the answer very short. 1.02. What is the ratio of the % of value added in manufacturing of Pakistan in 1972 to that in 1974?
Provide a succinct answer. 0.88. What is the ratio of the % of value added in manufacturing in Austria in 1972 to that in 1975?
Offer a very short reply. 1.14. What is the ratio of the % of value added in manufacturing of Pakistan in 1972 to that in 1975?
Your answer should be compact. 0.79. What is the ratio of the % of value added in manufacturing in Austria in 1973 to that in 1974?
Your response must be concise. 1.2. What is the ratio of the % of value added in manufacturing of Barbados in 1973 to that in 1974?
Offer a terse response. 0.91. What is the ratio of the % of value added in manufacturing of Congo (Republic) in 1973 to that in 1974?
Provide a succinct answer. 0.93. What is the ratio of the % of value added in manufacturing of Pakistan in 1973 to that in 1974?
Offer a very short reply. 0.89. What is the ratio of the % of value added in manufacturing of Austria in 1973 to that in 1975?
Offer a terse response. 1.08. What is the ratio of the % of value added in manufacturing of Barbados in 1973 to that in 1975?
Offer a very short reply. 0.88. What is the ratio of the % of value added in manufacturing in Congo (Republic) in 1973 to that in 1975?
Your answer should be very brief. 0.92. What is the ratio of the % of value added in manufacturing in Austria in 1974 to that in 1975?
Keep it short and to the point. 0.9. What is the ratio of the % of value added in manufacturing in Barbados in 1974 to that in 1975?
Ensure brevity in your answer.  0.98. What is the ratio of the % of value added in manufacturing of Congo (Republic) in 1974 to that in 1975?
Provide a short and direct response. 0.99. What is the ratio of the % of value added in manufacturing in Pakistan in 1974 to that in 1975?
Your response must be concise. 0.9. What is the difference between the highest and the second highest % of value added in manufacturing in Austria?
Provide a short and direct response. 0.06. What is the difference between the highest and the second highest % of value added in manufacturing in Barbados?
Keep it short and to the point. 0.05. What is the difference between the highest and the second highest % of value added in manufacturing in Congo (Republic)?
Your response must be concise. 7.93. What is the difference between the highest and the second highest % of value added in manufacturing in Pakistan?
Offer a terse response. 1.89. What is the difference between the highest and the lowest % of value added in manufacturing in Austria?
Your response must be concise. 3.48. What is the difference between the highest and the lowest % of value added in manufacturing in Barbados?
Offer a very short reply. 4.8. What is the difference between the highest and the lowest % of value added in manufacturing of Congo (Republic)?
Your answer should be compact. 15.6. What is the difference between the highest and the lowest % of value added in manufacturing in Pakistan?
Keep it short and to the point. 6.24. 